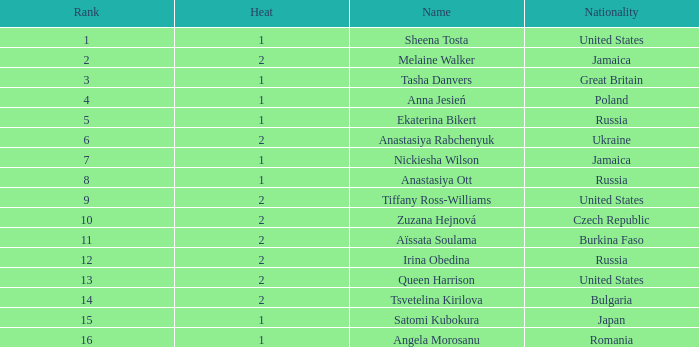Which Nationality has a Heat smaller than 2, and a Rank of 15? Japan. 